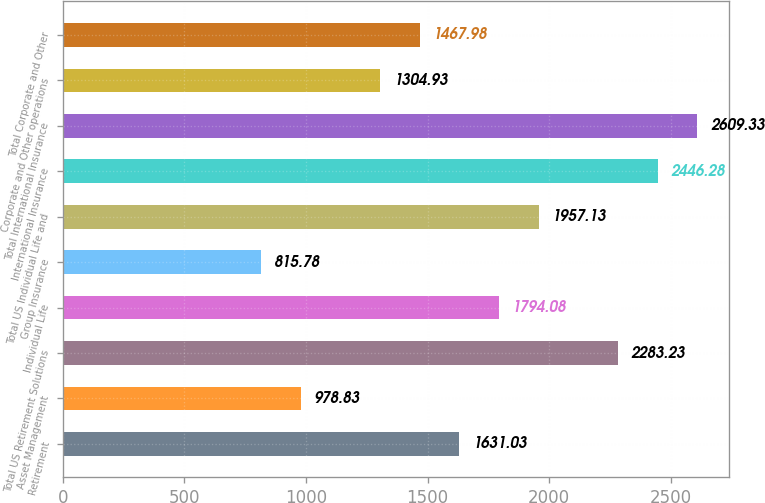Convert chart to OTSL. <chart><loc_0><loc_0><loc_500><loc_500><bar_chart><fcel>Retirement<fcel>Asset Management<fcel>Total US Retirement Solutions<fcel>Individual Life<fcel>Group Insurance<fcel>Total US Individual Life and<fcel>International Insurance<fcel>Total International Insurance<fcel>Corporate and Other operations<fcel>Total Corporate and Other<nl><fcel>1631.03<fcel>978.83<fcel>2283.23<fcel>1794.08<fcel>815.78<fcel>1957.13<fcel>2446.28<fcel>2609.33<fcel>1304.93<fcel>1467.98<nl></chart> 